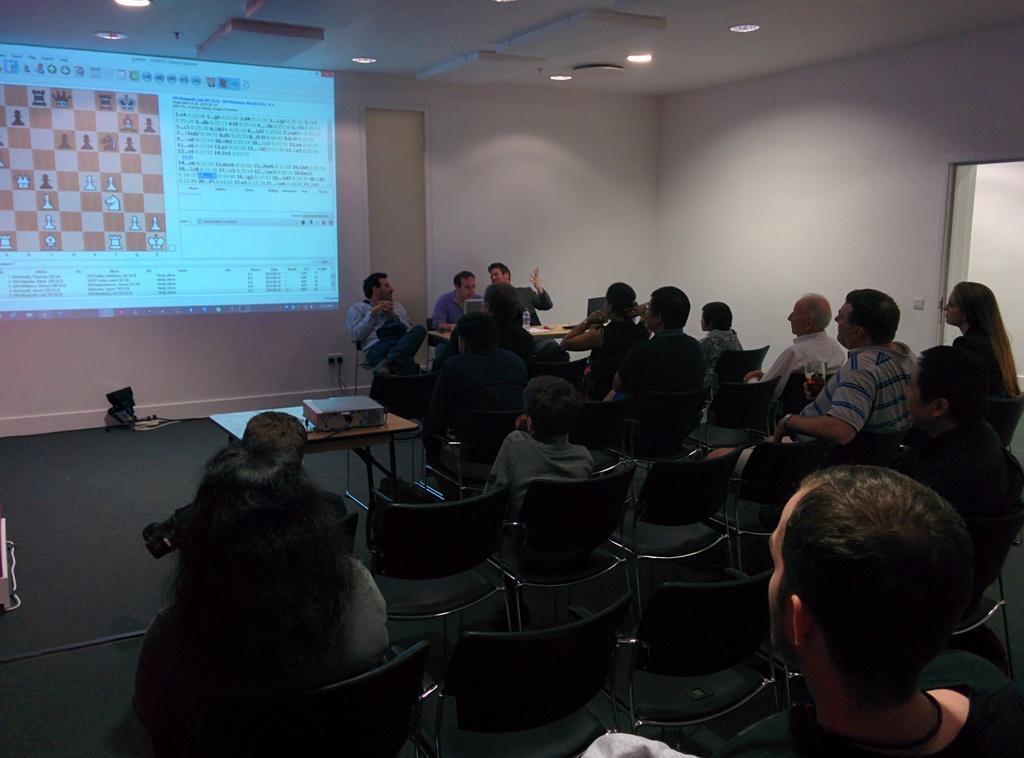Can you describe this image briefly? In this picture we can see a group of people sitting on chairs and a table with a device on it and in the background we can see the lights, walls, screen, bottle, cables and some objects. 